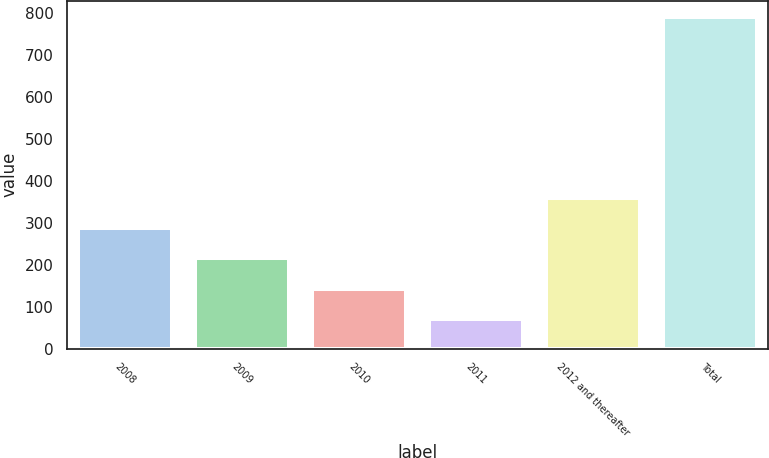Convert chart to OTSL. <chart><loc_0><loc_0><loc_500><loc_500><bar_chart><fcel>2008<fcel>2009<fcel>2010<fcel>2011<fcel>2012 and thereafter<fcel>Total<nl><fcel>286.7<fcel>214.8<fcel>142.9<fcel>71<fcel>358.6<fcel>790<nl></chart> 